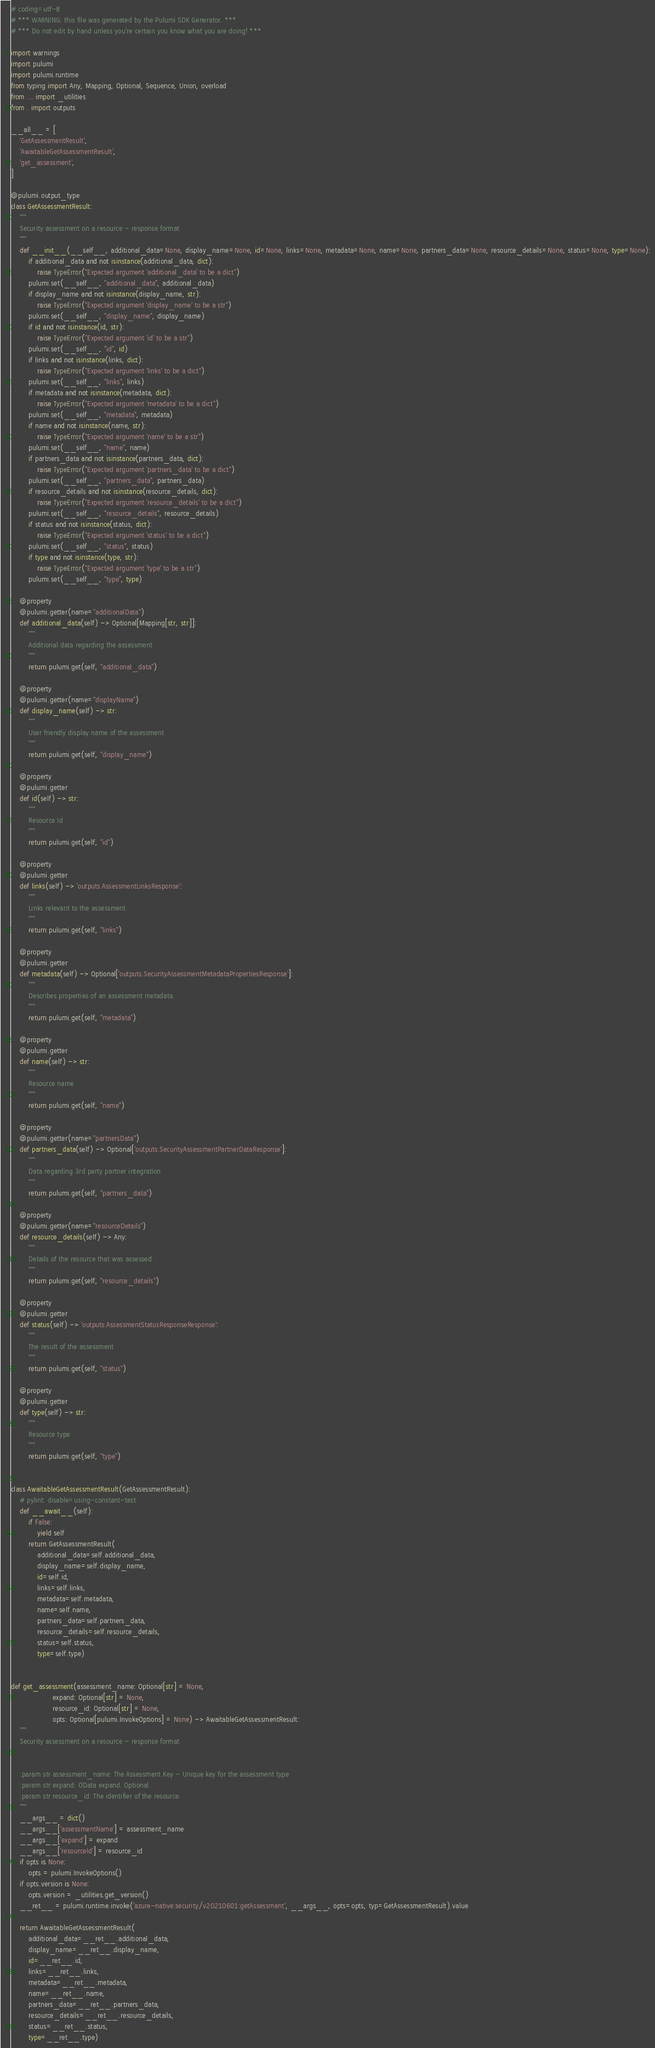<code> <loc_0><loc_0><loc_500><loc_500><_Python_># coding=utf-8
# *** WARNING: this file was generated by the Pulumi SDK Generator. ***
# *** Do not edit by hand unless you're certain you know what you are doing! ***

import warnings
import pulumi
import pulumi.runtime
from typing import Any, Mapping, Optional, Sequence, Union, overload
from ... import _utilities
from . import outputs

__all__ = [
    'GetAssessmentResult',
    'AwaitableGetAssessmentResult',
    'get_assessment',
]

@pulumi.output_type
class GetAssessmentResult:
    """
    Security assessment on a resource - response format
    """
    def __init__(__self__, additional_data=None, display_name=None, id=None, links=None, metadata=None, name=None, partners_data=None, resource_details=None, status=None, type=None):
        if additional_data and not isinstance(additional_data, dict):
            raise TypeError("Expected argument 'additional_data' to be a dict")
        pulumi.set(__self__, "additional_data", additional_data)
        if display_name and not isinstance(display_name, str):
            raise TypeError("Expected argument 'display_name' to be a str")
        pulumi.set(__self__, "display_name", display_name)
        if id and not isinstance(id, str):
            raise TypeError("Expected argument 'id' to be a str")
        pulumi.set(__self__, "id", id)
        if links and not isinstance(links, dict):
            raise TypeError("Expected argument 'links' to be a dict")
        pulumi.set(__self__, "links", links)
        if metadata and not isinstance(metadata, dict):
            raise TypeError("Expected argument 'metadata' to be a dict")
        pulumi.set(__self__, "metadata", metadata)
        if name and not isinstance(name, str):
            raise TypeError("Expected argument 'name' to be a str")
        pulumi.set(__self__, "name", name)
        if partners_data and not isinstance(partners_data, dict):
            raise TypeError("Expected argument 'partners_data' to be a dict")
        pulumi.set(__self__, "partners_data", partners_data)
        if resource_details and not isinstance(resource_details, dict):
            raise TypeError("Expected argument 'resource_details' to be a dict")
        pulumi.set(__self__, "resource_details", resource_details)
        if status and not isinstance(status, dict):
            raise TypeError("Expected argument 'status' to be a dict")
        pulumi.set(__self__, "status", status)
        if type and not isinstance(type, str):
            raise TypeError("Expected argument 'type' to be a str")
        pulumi.set(__self__, "type", type)

    @property
    @pulumi.getter(name="additionalData")
    def additional_data(self) -> Optional[Mapping[str, str]]:
        """
        Additional data regarding the assessment
        """
        return pulumi.get(self, "additional_data")

    @property
    @pulumi.getter(name="displayName")
    def display_name(self) -> str:
        """
        User friendly display name of the assessment
        """
        return pulumi.get(self, "display_name")

    @property
    @pulumi.getter
    def id(self) -> str:
        """
        Resource Id
        """
        return pulumi.get(self, "id")

    @property
    @pulumi.getter
    def links(self) -> 'outputs.AssessmentLinksResponse':
        """
        Links relevant to the assessment
        """
        return pulumi.get(self, "links")

    @property
    @pulumi.getter
    def metadata(self) -> Optional['outputs.SecurityAssessmentMetadataPropertiesResponse']:
        """
        Describes properties of an assessment metadata.
        """
        return pulumi.get(self, "metadata")

    @property
    @pulumi.getter
    def name(self) -> str:
        """
        Resource name
        """
        return pulumi.get(self, "name")

    @property
    @pulumi.getter(name="partnersData")
    def partners_data(self) -> Optional['outputs.SecurityAssessmentPartnerDataResponse']:
        """
        Data regarding 3rd party partner integration
        """
        return pulumi.get(self, "partners_data")

    @property
    @pulumi.getter(name="resourceDetails")
    def resource_details(self) -> Any:
        """
        Details of the resource that was assessed
        """
        return pulumi.get(self, "resource_details")

    @property
    @pulumi.getter
    def status(self) -> 'outputs.AssessmentStatusResponseResponse':
        """
        The result of the assessment
        """
        return pulumi.get(self, "status")

    @property
    @pulumi.getter
    def type(self) -> str:
        """
        Resource type
        """
        return pulumi.get(self, "type")


class AwaitableGetAssessmentResult(GetAssessmentResult):
    # pylint: disable=using-constant-test
    def __await__(self):
        if False:
            yield self
        return GetAssessmentResult(
            additional_data=self.additional_data,
            display_name=self.display_name,
            id=self.id,
            links=self.links,
            metadata=self.metadata,
            name=self.name,
            partners_data=self.partners_data,
            resource_details=self.resource_details,
            status=self.status,
            type=self.type)


def get_assessment(assessment_name: Optional[str] = None,
                   expand: Optional[str] = None,
                   resource_id: Optional[str] = None,
                   opts: Optional[pulumi.InvokeOptions] = None) -> AwaitableGetAssessmentResult:
    """
    Security assessment on a resource - response format


    :param str assessment_name: The Assessment Key - Unique key for the assessment type
    :param str expand: OData expand. Optional.
    :param str resource_id: The identifier of the resource.
    """
    __args__ = dict()
    __args__['assessmentName'] = assessment_name
    __args__['expand'] = expand
    __args__['resourceId'] = resource_id
    if opts is None:
        opts = pulumi.InvokeOptions()
    if opts.version is None:
        opts.version = _utilities.get_version()
    __ret__ = pulumi.runtime.invoke('azure-native:security/v20210601:getAssessment', __args__, opts=opts, typ=GetAssessmentResult).value

    return AwaitableGetAssessmentResult(
        additional_data=__ret__.additional_data,
        display_name=__ret__.display_name,
        id=__ret__.id,
        links=__ret__.links,
        metadata=__ret__.metadata,
        name=__ret__.name,
        partners_data=__ret__.partners_data,
        resource_details=__ret__.resource_details,
        status=__ret__.status,
        type=__ret__.type)
</code> 